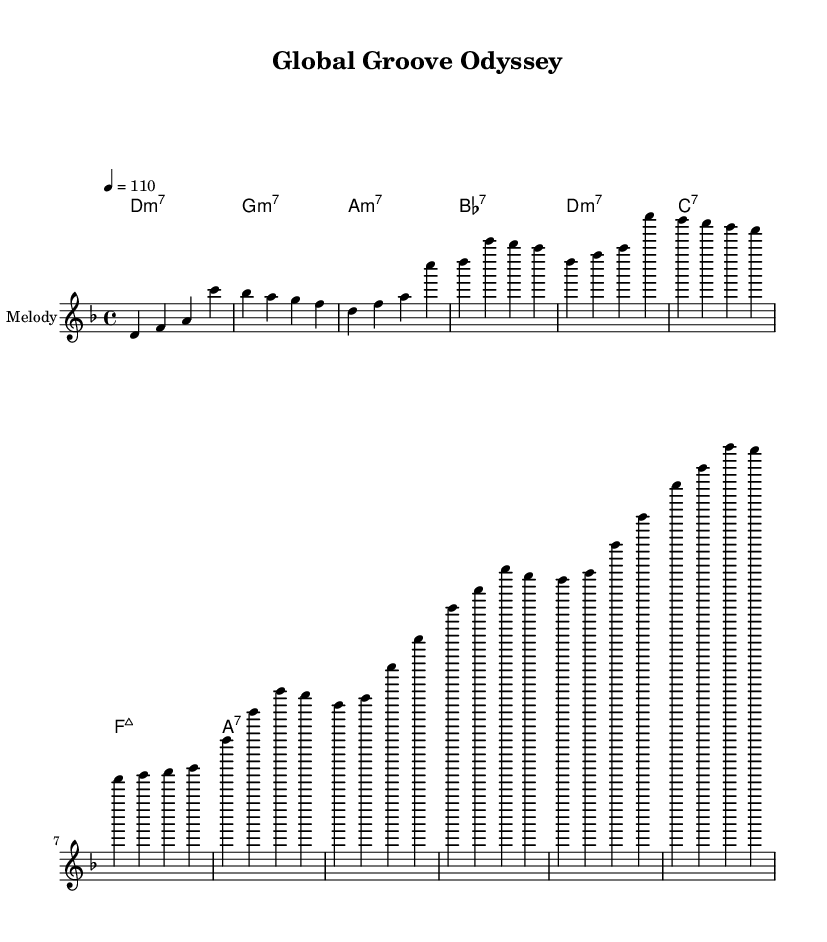What is the key signature of this music? The key signature is D minor, indicated by one flat (B flat) in the sheet music, which corresponds to the key where D is the tonic.
Answer: D minor What is the time signature of this music? The time signature of the piece is 4/4, as indicated at the beginning of the score, which means there are four beats in each measure, and a quarter note receives one beat.
Answer: 4/4 What is the tempo marking? The tempo marking at the beginning indicates a speed of dotted quarter note = 110 beats per minute, which provides a lively pace typical for funk music.
Answer: 110 What is the first chord of the piece? The first chord displayed in the harmony section is D minor 7, which is indicated as "d1:m7" in the chord names.
Answer: D minor 7 How many measures are in the main theme of the melody? Counting the measures provided in the melody section, there are a total of 4 measures in the main theme, which is clearly divided as seen in the layout of notes.
Answer: 4 How does the chord progression illustrate funk characteristics? The chord progression features extended chords like D minor 7 and G minor 7, which add harmonic richness and sophistication, typical in funk music, allowing for more expressive rhythm and groove patterns.
Answer: Extended chords What section follows the verse in the piece? The section that follows the verse is called the chorus, which is indicated in the melody section and provides a contrasting and typically catchier musical idea in funk compositions.
Answer: Chorus 